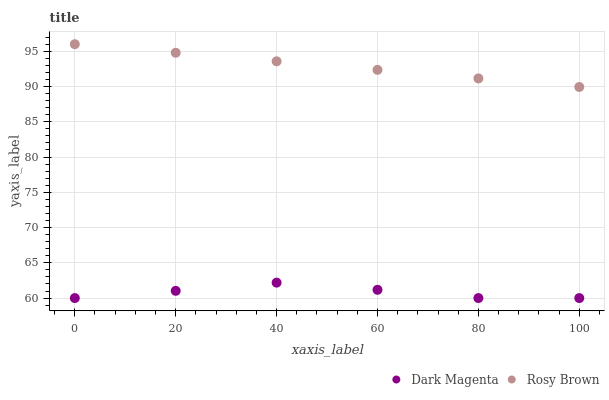Does Dark Magenta have the minimum area under the curve?
Answer yes or no. Yes. Does Rosy Brown have the maximum area under the curve?
Answer yes or no. Yes. Does Dark Magenta have the maximum area under the curve?
Answer yes or no. No. Is Rosy Brown the smoothest?
Answer yes or no. Yes. Is Dark Magenta the roughest?
Answer yes or no. Yes. Is Dark Magenta the smoothest?
Answer yes or no. No. Does Dark Magenta have the lowest value?
Answer yes or no. Yes. Does Rosy Brown have the highest value?
Answer yes or no. Yes. Does Dark Magenta have the highest value?
Answer yes or no. No. Is Dark Magenta less than Rosy Brown?
Answer yes or no. Yes. Is Rosy Brown greater than Dark Magenta?
Answer yes or no. Yes. Does Dark Magenta intersect Rosy Brown?
Answer yes or no. No. 